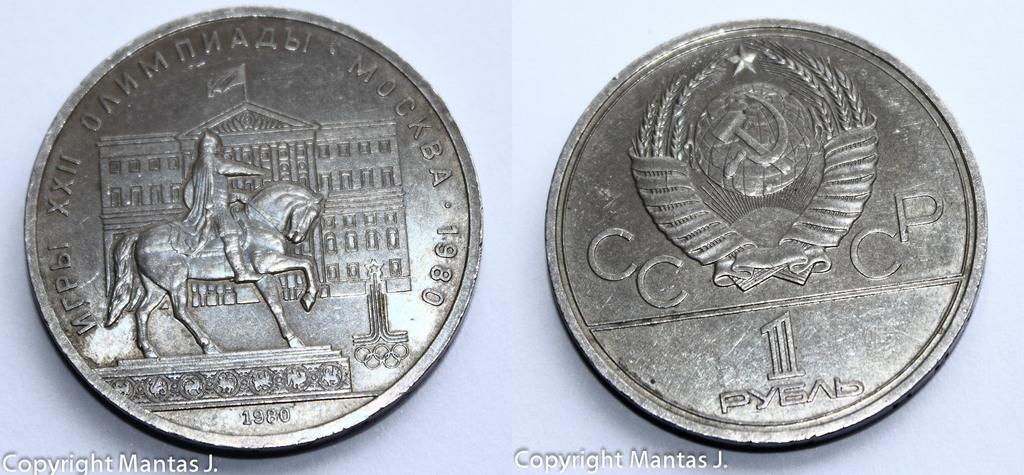<image>
Summarize the visual content of the image. Two coins next to one another wiht one from the year 1800. 